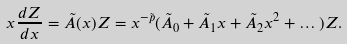Convert formula to latex. <formula><loc_0><loc_0><loc_500><loc_500>x \frac { d Z } { d x } = \tilde { A } ( x ) Z = x ^ { - \tilde { p } } ( \tilde { A } _ { 0 } + \tilde { A } _ { 1 } x + \tilde { A } _ { 2 } x ^ { 2 } + \dots ) Z .</formula> 